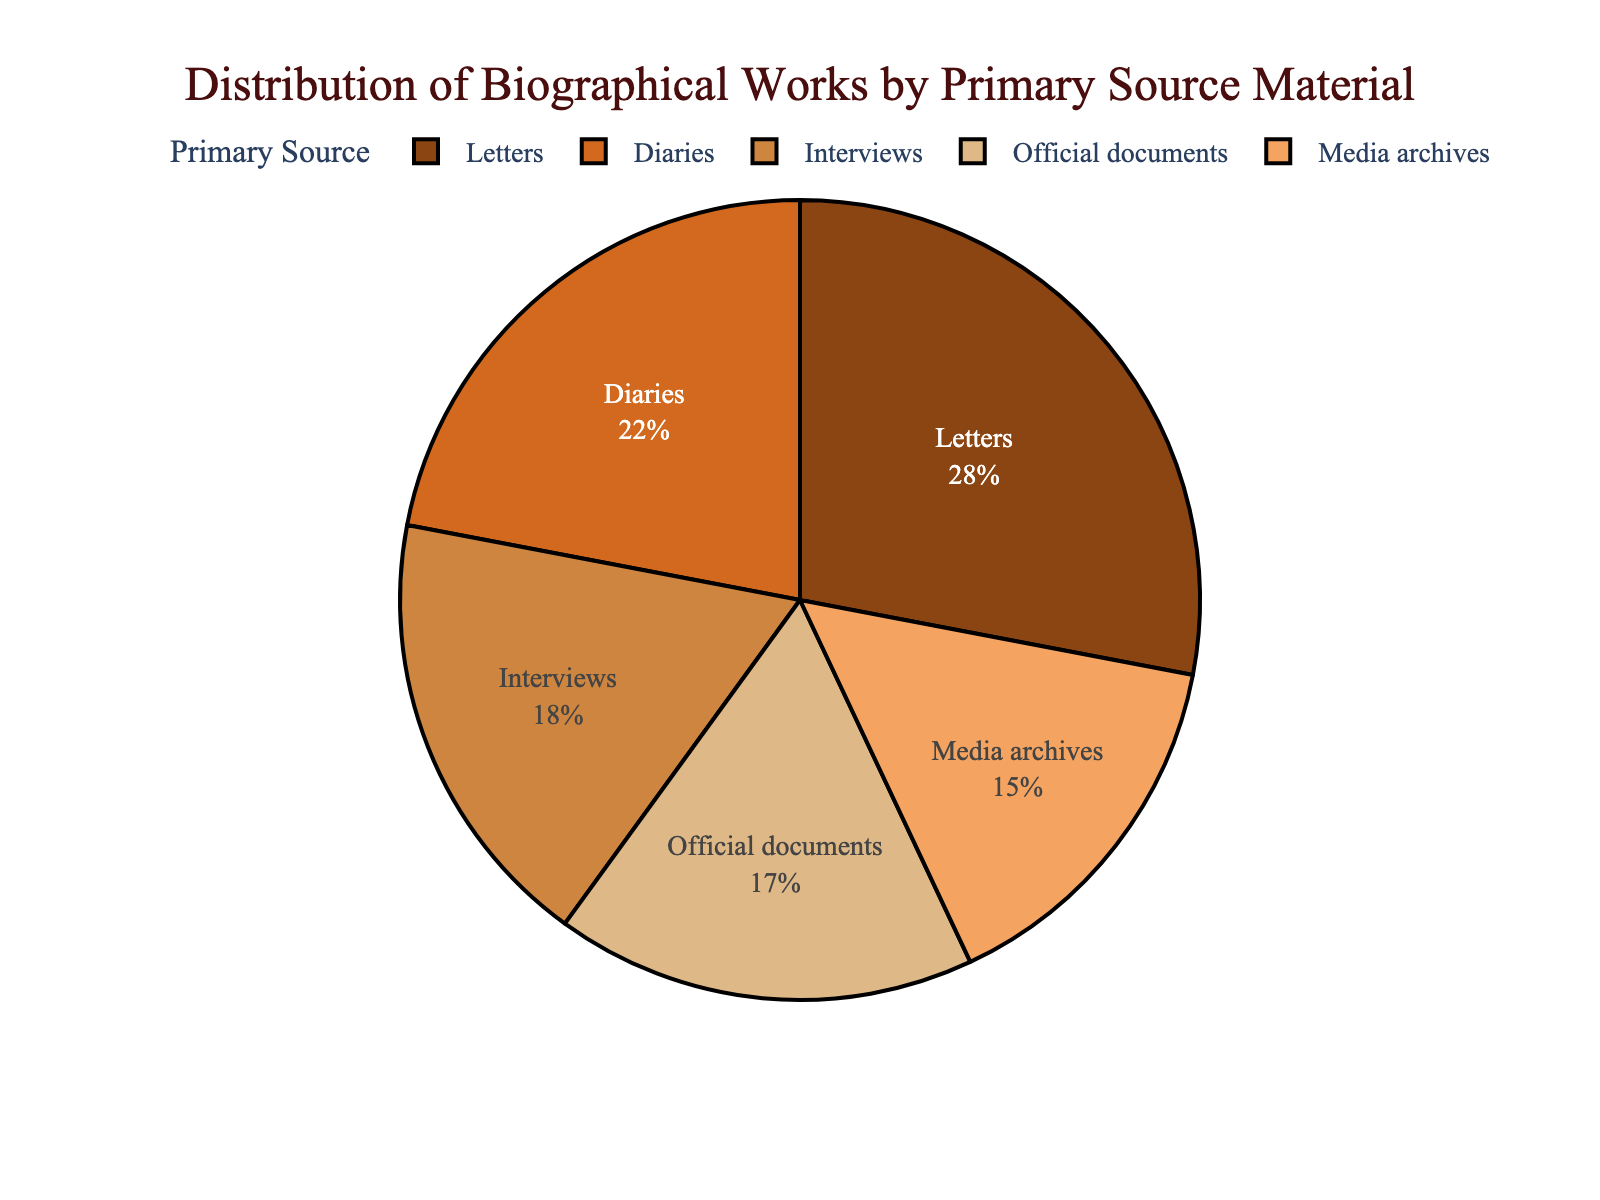Which primary source has the highest percentage of use in biographical works? The figure shows different primary sources with their respective percentages. The segment with the highest percentage is the largest portion of the pie chart. In this case, Letters have the highest percentage.
Answer: Letters How much more is the percentage of Letters compared to Diaries? To find the difference, subtract the percentage of Diaries (22%) from the percentage of Letters (28%). 28% - 22% = 6%
Answer: 6% What's the combined percentage of biographical works that use Interviews and Official documents? Add the percentages for Interviews (18%) and Official documents (17%). 18% + 17% = 35%
Answer: 35% Which primary source has the second smallest percentage of use, and what is that percentage? The pie chart segments reveal the percentages for each primary source. Media archives have the smallest, which is 15%. The second smallest is Official documents with 17%.
Answer: Official documents, 17% How does the percentage of Media archives compare to that of Diaries? Compare the two percentages: Media archives (15%) and Diaries (22%). Diaries have a higher percentage than Media archives.
Answer: Less If we exclude Letters, what is the average percentage of the remaining primary sources? First, add the percentages of the remaining sources: Diaries (22%) + Interviews (18%) + Official documents (17%) + Media archives (15%) = 72%. Next, divide by the number of sources (4). 72% / 4 = 18%
Answer: 18% What's the percentage difference between the most and least used primary sources? Subtract the percentage of the least used source (Media archives, 15%) from the most used source (Letters, 28%). 28% - 15% = 13%
Answer: 13% Which two primary sources together make up exactly 50% of the biographical works, if any? Check each possible pair to sum up their percentages. Diaries (22%) and Interviews (18%) together is 40%; Interviews (18%) and Official documents (17%) together is 35%; ultimately, Diaries (22%) and Media archives (15%) together is 37%. No pair sums to exactly 50%.
Answer: None 